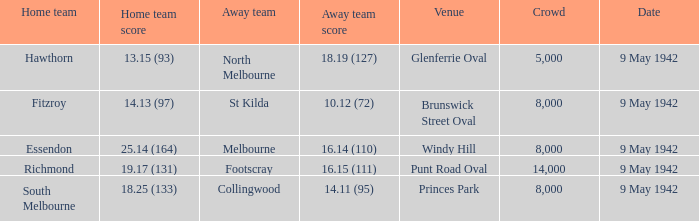How many spectators were there at the game when footscray played away? 14000.0. 